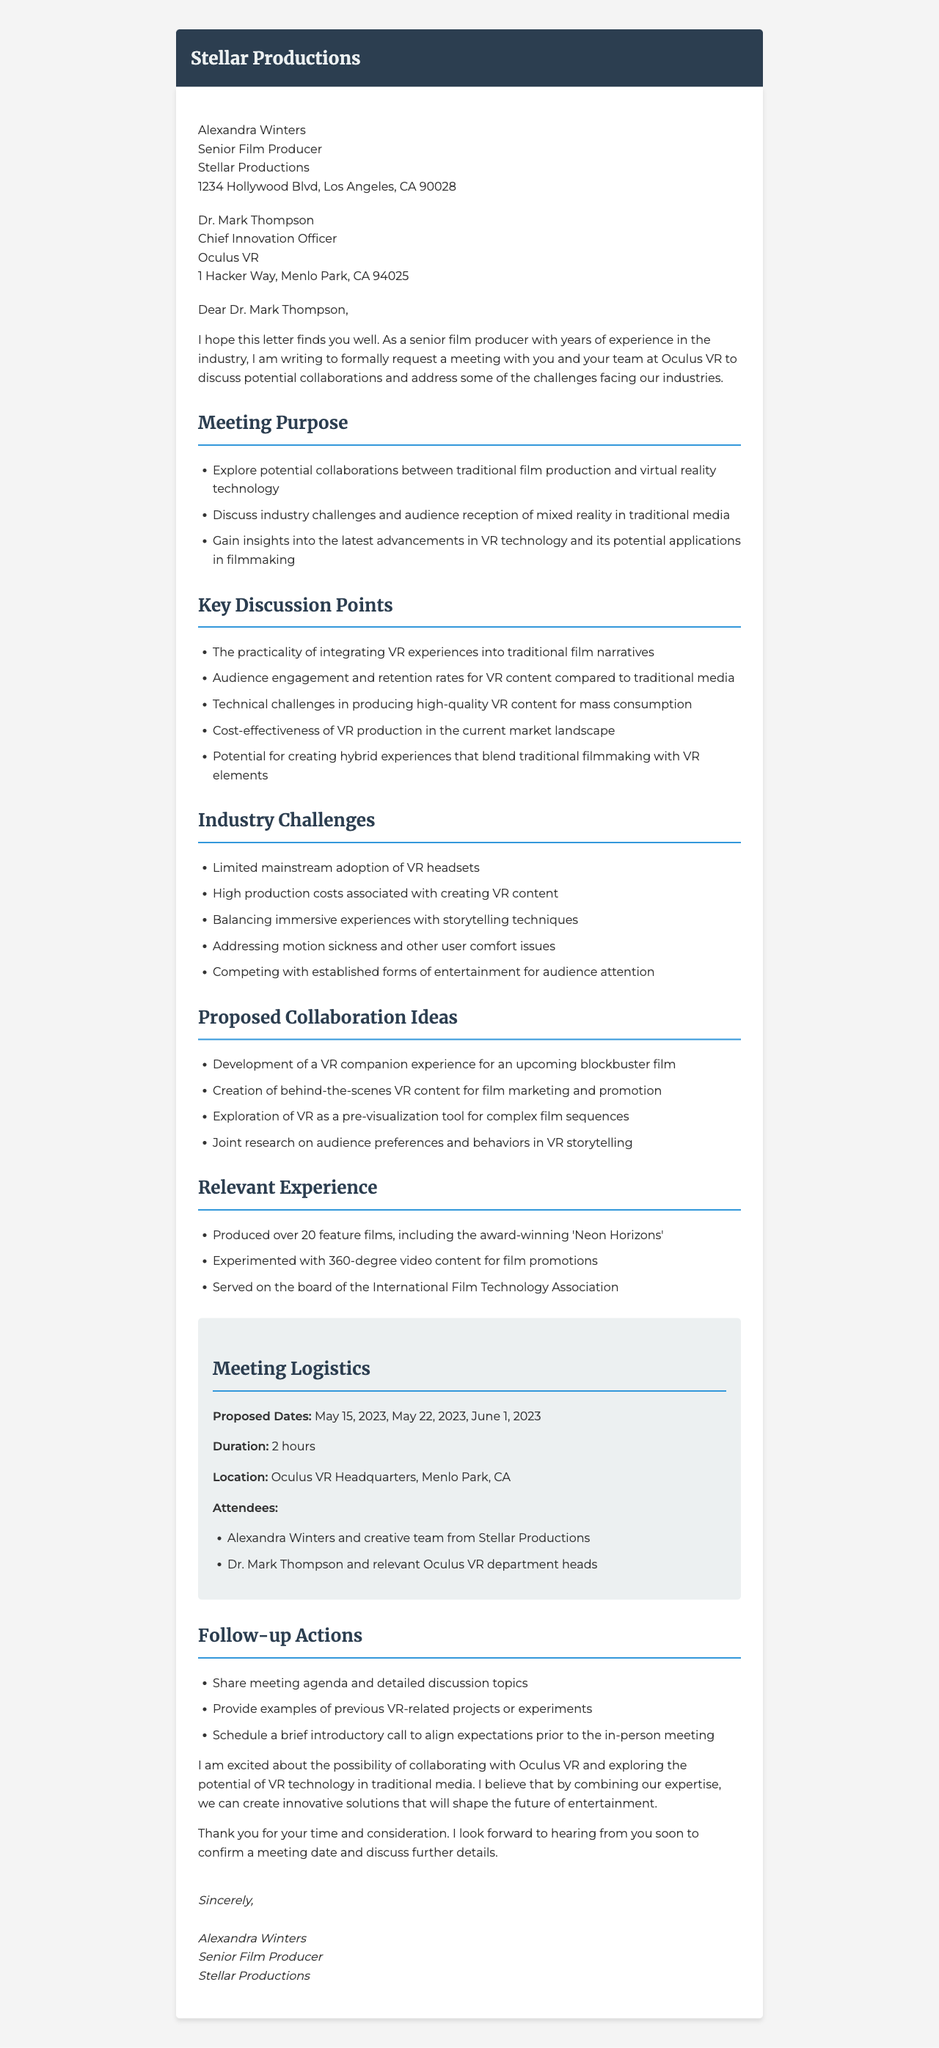what is the sender's name? The sender's name is mentioned at the beginning of the document as Alexandra Winters.
Answer: Alexandra Winters who is the recipient of the letter? The recipient's information is provided in the document, specifically listed as Dr. Mark Thompson.
Answer: Dr. Mark Thompson what is the proposed date for the meeting? The document lists several proposed dates for the meeting, including May 15, 2023.
Answer: May 15, 2023 what is one of the key discussion points? The document enumerates key discussion points, one of which is the integration of VR into film narratives.
Answer: The practicality of integrating VR experiences into traditional film narratives which company is being contacted? The letter addresses the communication towards a specific company identified in the recipient's information.
Answer: Oculus VR how long is the meeting expected to last? The duration of the meeting is explicitly stated in the document.
Answer: 2 hours what is a proposed collaboration idea? The document lists potential collaboration ideas, including the development of VR companion experiences.
Answer: Development of a VR companion experience for an upcoming blockbuster film what industry challenge is mentioned? The letter outlines challenges faced in the industry, such as limited mainstream adoption of VR headsets.
Answer: Limited mainstream adoption of VR headsets what is the title of the sender? The sender's title is stated in their information section, providing insight into their professional role.
Answer: Senior Film Producer 